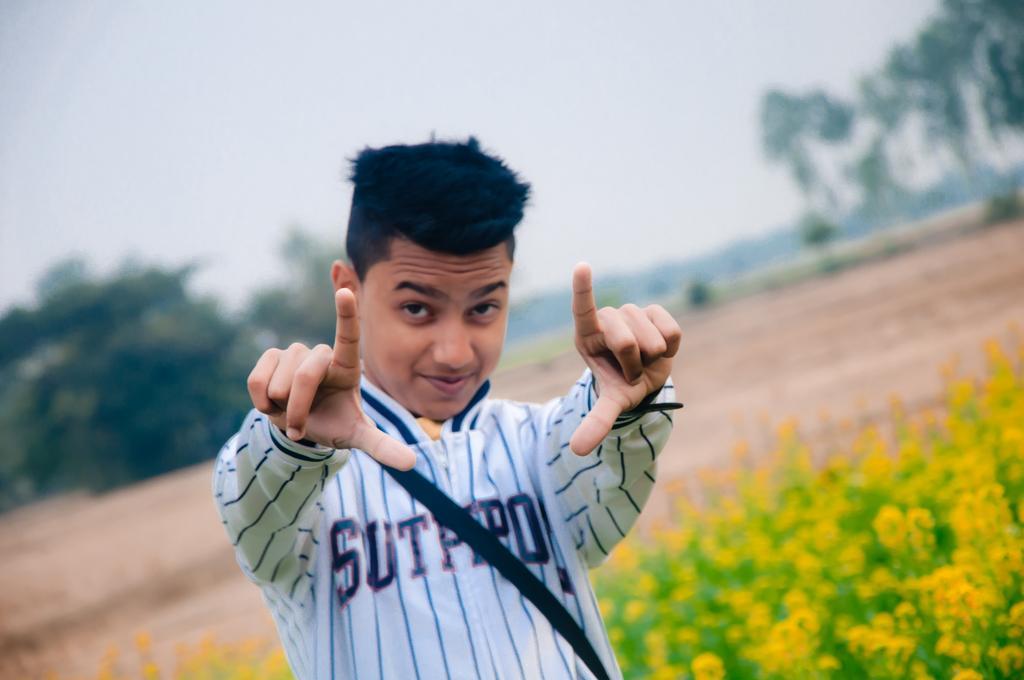Can you describe this image briefly? In the image we can see a man wearing clothes. These are the flower plants, trees and a sky, and the background is blurred. 